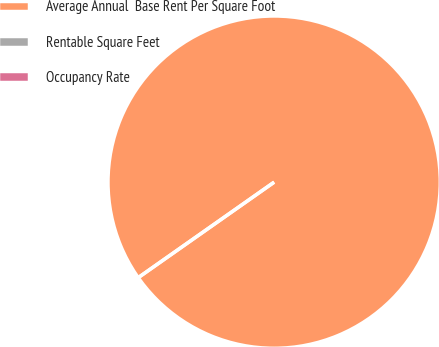<chart> <loc_0><loc_0><loc_500><loc_500><pie_chart><fcel>Average Annual  Base Rent Per Square Foot<fcel>Rentable Square Feet<fcel>Occupancy Rate<nl><fcel>100.0%<fcel>0.0%<fcel>0.0%<nl></chart> 